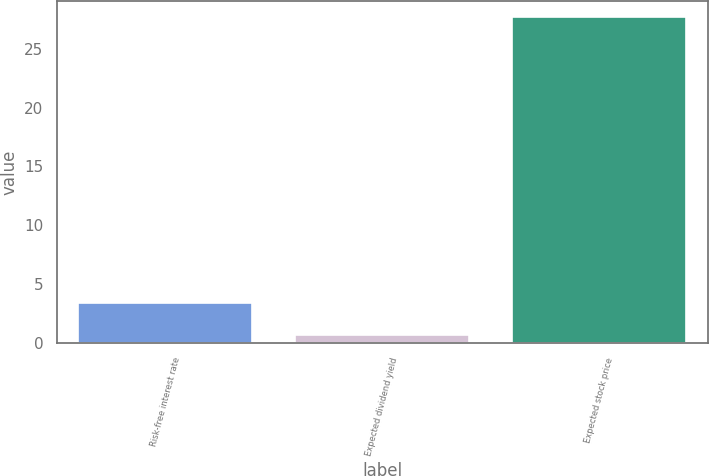<chart> <loc_0><loc_0><loc_500><loc_500><bar_chart><fcel>Risk-free interest rate<fcel>Expected dividend yield<fcel>Expected stock price<nl><fcel>3.4<fcel>0.7<fcel>27.7<nl></chart> 